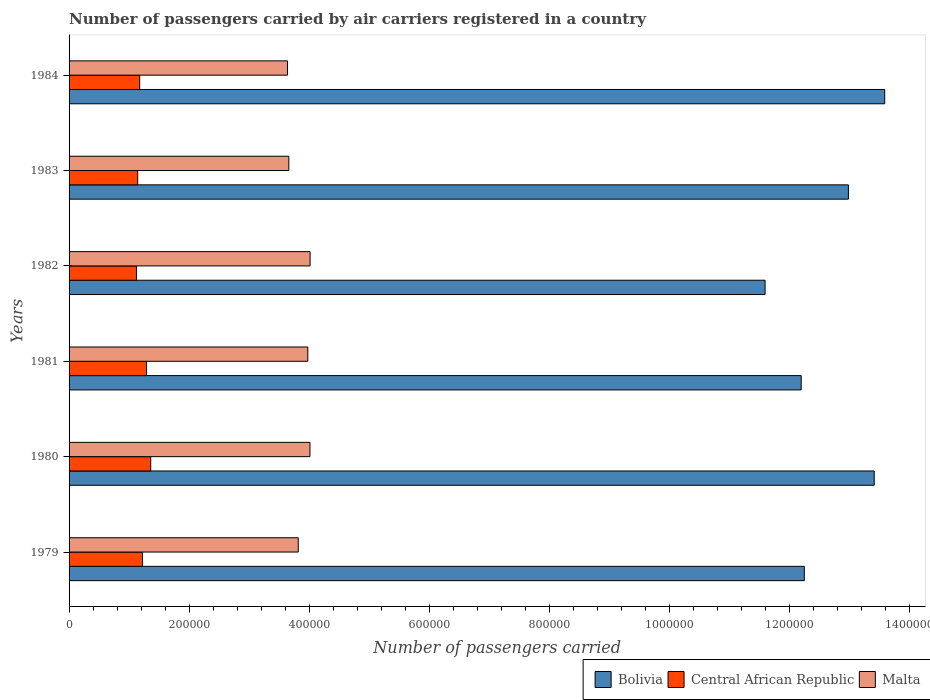How many bars are there on the 4th tick from the top?
Your response must be concise. 3. How many bars are there on the 5th tick from the bottom?
Your answer should be compact. 3. What is the label of the 5th group of bars from the top?
Offer a terse response. 1980. In how many cases, is the number of bars for a given year not equal to the number of legend labels?
Your response must be concise. 0. What is the number of passengers carried by air carriers in Bolivia in 1980?
Your answer should be compact. 1.34e+06. Across all years, what is the maximum number of passengers carried by air carriers in Malta?
Make the answer very short. 4.02e+05. Across all years, what is the minimum number of passengers carried by air carriers in Malta?
Keep it short and to the point. 3.64e+05. What is the total number of passengers carried by air carriers in Bolivia in the graph?
Keep it short and to the point. 7.61e+06. What is the difference between the number of passengers carried by air carriers in Bolivia in 1983 and that in 1984?
Offer a very short reply. -6.05e+04. What is the difference between the number of passengers carried by air carriers in Bolivia in 1979 and the number of passengers carried by air carriers in Malta in 1982?
Ensure brevity in your answer.  8.24e+05. What is the average number of passengers carried by air carriers in Bolivia per year?
Keep it short and to the point. 1.27e+06. In the year 1979, what is the difference between the number of passengers carried by air carriers in Bolivia and number of passengers carried by air carriers in Central African Republic?
Provide a short and direct response. 1.10e+06. In how many years, is the number of passengers carried by air carriers in Malta greater than 840000 ?
Provide a short and direct response. 0. What is the ratio of the number of passengers carried by air carriers in Bolivia in 1982 to that in 1984?
Give a very brief answer. 0.85. What is the difference between the highest and the second highest number of passengers carried by air carriers in Central African Republic?
Offer a terse response. 7000. What is the difference between the highest and the lowest number of passengers carried by air carriers in Central African Republic?
Provide a short and direct response. 2.38e+04. What does the 2nd bar from the top in 1979 represents?
Provide a short and direct response. Central African Republic. What does the 3rd bar from the bottom in 1982 represents?
Offer a terse response. Malta. Is it the case that in every year, the sum of the number of passengers carried by air carriers in Malta and number of passengers carried by air carriers in Bolivia is greater than the number of passengers carried by air carriers in Central African Republic?
Make the answer very short. Yes. Are all the bars in the graph horizontal?
Your answer should be very brief. Yes. What is the difference between two consecutive major ticks on the X-axis?
Your response must be concise. 2.00e+05. Does the graph contain any zero values?
Your response must be concise. No. How many legend labels are there?
Ensure brevity in your answer.  3. What is the title of the graph?
Provide a succinct answer. Number of passengers carried by air carriers registered in a country. What is the label or title of the X-axis?
Provide a short and direct response. Number of passengers carried. What is the label or title of the Y-axis?
Your answer should be very brief. Years. What is the Number of passengers carried of Bolivia in 1979?
Make the answer very short. 1.23e+06. What is the Number of passengers carried in Central African Republic in 1979?
Ensure brevity in your answer.  1.22e+05. What is the Number of passengers carried of Malta in 1979?
Provide a succinct answer. 3.82e+05. What is the Number of passengers carried in Bolivia in 1980?
Provide a short and direct response. 1.34e+06. What is the Number of passengers carried of Central African Republic in 1980?
Keep it short and to the point. 1.36e+05. What is the Number of passengers carried in Malta in 1980?
Provide a succinct answer. 4.02e+05. What is the Number of passengers carried of Bolivia in 1981?
Provide a succinct answer. 1.22e+06. What is the Number of passengers carried in Central African Republic in 1981?
Your response must be concise. 1.29e+05. What is the Number of passengers carried of Malta in 1981?
Give a very brief answer. 3.98e+05. What is the Number of passengers carried of Bolivia in 1982?
Your response must be concise. 1.16e+06. What is the Number of passengers carried in Central African Republic in 1982?
Your answer should be compact. 1.12e+05. What is the Number of passengers carried in Malta in 1982?
Offer a terse response. 4.02e+05. What is the Number of passengers carried of Bolivia in 1983?
Give a very brief answer. 1.30e+06. What is the Number of passengers carried in Central African Republic in 1983?
Offer a very short reply. 1.14e+05. What is the Number of passengers carried in Malta in 1983?
Keep it short and to the point. 3.66e+05. What is the Number of passengers carried in Bolivia in 1984?
Offer a very short reply. 1.36e+06. What is the Number of passengers carried of Central African Republic in 1984?
Your answer should be very brief. 1.18e+05. What is the Number of passengers carried in Malta in 1984?
Your response must be concise. 3.64e+05. Across all years, what is the maximum Number of passengers carried of Bolivia?
Make the answer very short. 1.36e+06. Across all years, what is the maximum Number of passengers carried in Central African Republic?
Give a very brief answer. 1.36e+05. Across all years, what is the maximum Number of passengers carried of Malta?
Offer a terse response. 4.02e+05. Across all years, what is the minimum Number of passengers carried in Bolivia?
Offer a very short reply. 1.16e+06. Across all years, what is the minimum Number of passengers carried of Central African Republic?
Ensure brevity in your answer.  1.12e+05. Across all years, what is the minimum Number of passengers carried of Malta?
Make the answer very short. 3.64e+05. What is the total Number of passengers carried in Bolivia in the graph?
Make the answer very short. 7.61e+06. What is the total Number of passengers carried in Central African Republic in the graph?
Give a very brief answer. 7.32e+05. What is the total Number of passengers carried in Malta in the graph?
Keep it short and to the point. 2.31e+06. What is the difference between the Number of passengers carried of Bolivia in 1979 and that in 1980?
Ensure brevity in your answer.  -1.16e+05. What is the difference between the Number of passengers carried in Central African Republic in 1979 and that in 1980?
Your answer should be very brief. -1.38e+04. What is the difference between the Number of passengers carried in Malta in 1979 and that in 1980?
Offer a terse response. -1.95e+04. What is the difference between the Number of passengers carried in Bolivia in 1979 and that in 1981?
Provide a short and direct response. 5200. What is the difference between the Number of passengers carried in Central African Republic in 1979 and that in 1981?
Offer a very short reply. -6800. What is the difference between the Number of passengers carried in Malta in 1979 and that in 1981?
Ensure brevity in your answer.  -1.59e+04. What is the difference between the Number of passengers carried in Bolivia in 1979 and that in 1982?
Keep it short and to the point. 6.54e+04. What is the difference between the Number of passengers carried in Malta in 1979 and that in 1982?
Offer a very short reply. -1.97e+04. What is the difference between the Number of passengers carried of Bolivia in 1979 and that in 1983?
Your answer should be very brief. -7.35e+04. What is the difference between the Number of passengers carried of Central African Republic in 1979 and that in 1983?
Offer a very short reply. 7900. What is the difference between the Number of passengers carried of Malta in 1979 and that in 1983?
Ensure brevity in your answer.  1.57e+04. What is the difference between the Number of passengers carried in Bolivia in 1979 and that in 1984?
Provide a succinct answer. -1.34e+05. What is the difference between the Number of passengers carried of Central African Republic in 1979 and that in 1984?
Ensure brevity in your answer.  4600. What is the difference between the Number of passengers carried of Malta in 1979 and that in 1984?
Your response must be concise. 1.79e+04. What is the difference between the Number of passengers carried in Bolivia in 1980 and that in 1981?
Your answer should be compact. 1.22e+05. What is the difference between the Number of passengers carried in Central African Republic in 1980 and that in 1981?
Offer a terse response. 7000. What is the difference between the Number of passengers carried in Malta in 1980 and that in 1981?
Your answer should be compact. 3600. What is the difference between the Number of passengers carried in Bolivia in 1980 and that in 1982?
Provide a succinct answer. 1.82e+05. What is the difference between the Number of passengers carried of Central African Republic in 1980 and that in 1982?
Give a very brief answer. 2.38e+04. What is the difference between the Number of passengers carried of Malta in 1980 and that in 1982?
Offer a very short reply. -200. What is the difference between the Number of passengers carried of Bolivia in 1980 and that in 1983?
Keep it short and to the point. 4.30e+04. What is the difference between the Number of passengers carried in Central African Republic in 1980 and that in 1983?
Your response must be concise. 2.17e+04. What is the difference between the Number of passengers carried of Malta in 1980 and that in 1983?
Keep it short and to the point. 3.52e+04. What is the difference between the Number of passengers carried of Bolivia in 1980 and that in 1984?
Your response must be concise. -1.75e+04. What is the difference between the Number of passengers carried of Central African Republic in 1980 and that in 1984?
Provide a succinct answer. 1.84e+04. What is the difference between the Number of passengers carried of Malta in 1980 and that in 1984?
Your response must be concise. 3.74e+04. What is the difference between the Number of passengers carried in Bolivia in 1981 and that in 1982?
Provide a succinct answer. 6.02e+04. What is the difference between the Number of passengers carried of Central African Republic in 1981 and that in 1982?
Provide a succinct answer. 1.68e+04. What is the difference between the Number of passengers carried of Malta in 1981 and that in 1982?
Your response must be concise. -3800. What is the difference between the Number of passengers carried of Bolivia in 1981 and that in 1983?
Provide a short and direct response. -7.87e+04. What is the difference between the Number of passengers carried of Central African Republic in 1981 and that in 1983?
Your response must be concise. 1.47e+04. What is the difference between the Number of passengers carried of Malta in 1981 and that in 1983?
Your answer should be compact. 3.16e+04. What is the difference between the Number of passengers carried in Bolivia in 1981 and that in 1984?
Your answer should be very brief. -1.39e+05. What is the difference between the Number of passengers carried in Central African Republic in 1981 and that in 1984?
Keep it short and to the point. 1.14e+04. What is the difference between the Number of passengers carried in Malta in 1981 and that in 1984?
Provide a short and direct response. 3.38e+04. What is the difference between the Number of passengers carried in Bolivia in 1982 and that in 1983?
Keep it short and to the point. -1.39e+05. What is the difference between the Number of passengers carried in Central African Republic in 1982 and that in 1983?
Provide a short and direct response. -2100. What is the difference between the Number of passengers carried of Malta in 1982 and that in 1983?
Your answer should be compact. 3.54e+04. What is the difference between the Number of passengers carried of Bolivia in 1982 and that in 1984?
Offer a very short reply. -1.99e+05. What is the difference between the Number of passengers carried in Central African Republic in 1982 and that in 1984?
Make the answer very short. -5400. What is the difference between the Number of passengers carried of Malta in 1982 and that in 1984?
Ensure brevity in your answer.  3.76e+04. What is the difference between the Number of passengers carried in Bolivia in 1983 and that in 1984?
Provide a short and direct response. -6.05e+04. What is the difference between the Number of passengers carried of Central African Republic in 1983 and that in 1984?
Give a very brief answer. -3300. What is the difference between the Number of passengers carried in Malta in 1983 and that in 1984?
Your answer should be very brief. 2200. What is the difference between the Number of passengers carried in Bolivia in 1979 and the Number of passengers carried in Central African Republic in 1980?
Your answer should be compact. 1.09e+06. What is the difference between the Number of passengers carried of Bolivia in 1979 and the Number of passengers carried of Malta in 1980?
Offer a terse response. 8.24e+05. What is the difference between the Number of passengers carried in Central African Republic in 1979 and the Number of passengers carried in Malta in 1980?
Keep it short and to the point. -2.79e+05. What is the difference between the Number of passengers carried of Bolivia in 1979 and the Number of passengers carried of Central African Republic in 1981?
Offer a terse response. 1.10e+06. What is the difference between the Number of passengers carried in Bolivia in 1979 and the Number of passengers carried in Malta in 1981?
Offer a very short reply. 8.28e+05. What is the difference between the Number of passengers carried of Central African Republic in 1979 and the Number of passengers carried of Malta in 1981?
Ensure brevity in your answer.  -2.76e+05. What is the difference between the Number of passengers carried of Bolivia in 1979 and the Number of passengers carried of Central African Republic in 1982?
Give a very brief answer. 1.11e+06. What is the difference between the Number of passengers carried in Bolivia in 1979 and the Number of passengers carried in Malta in 1982?
Make the answer very short. 8.24e+05. What is the difference between the Number of passengers carried in Central African Republic in 1979 and the Number of passengers carried in Malta in 1982?
Your response must be concise. -2.79e+05. What is the difference between the Number of passengers carried in Bolivia in 1979 and the Number of passengers carried in Central African Republic in 1983?
Offer a terse response. 1.11e+06. What is the difference between the Number of passengers carried of Bolivia in 1979 and the Number of passengers carried of Malta in 1983?
Your answer should be very brief. 8.59e+05. What is the difference between the Number of passengers carried of Central African Republic in 1979 and the Number of passengers carried of Malta in 1983?
Ensure brevity in your answer.  -2.44e+05. What is the difference between the Number of passengers carried in Bolivia in 1979 and the Number of passengers carried in Central African Republic in 1984?
Provide a succinct answer. 1.11e+06. What is the difference between the Number of passengers carried in Bolivia in 1979 and the Number of passengers carried in Malta in 1984?
Make the answer very short. 8.61e+05. What is the difference between the Number of passengers carried in Central African Republic in 1979 and the Number of passengers carried in Malta in 1984?
Ensure brevity in your answer.  -2.42e+05. What is the difference between the Number of passengers carried of Bolivia in 1980 and the Number of passengers carried of Central African Republic in 1981?
Give a very brief answer. 1.21e+06. What is the difference between the Number of passengers carried in Bolivia in 1980 and the Number of passengers carried in Malta in 1981?
Your answer should be compact. 9.44e+05. What is the difference between the Number of passengers carried in Central African Republic in 1980 and the Number of passengers carried in Malta in 1981?
Provide a short and direct response. -2.62e+05. What is the difference between the Number of passengers carried in Bolivia in 1980 and the Number of passengers carried in Central African Republic in 1982?
Your answer should be compact. 1.23e+06. What is the difference between the Number of passengers carried in Bolivia in 1980 and the Number of passengers carried in Malta in 1982?
Your answer should be very brief. 9.40e+05. What is the difference between the Number of passengers carried of Central African Republic in 1980 and the Number of passengers carried of Malta in 1982?
Keep it short and to the point. -2.66e+05. What is the difference between the Number of passengers carried in Bolivia in 1980 and the Number of passengers carried in Central African Republic in 1983?
Give a very brief answer. 1.23e+06. What is the difference between the Number of passengers carried in Bolivia in 1980 and the Number of passengers carried in Malta in 1983?
Your answer should be very brief. 9.76e+05. What is the difference between the Number of passengers carried in Central African Republic in 1980 and the Number of passengers carried in Malta in 1983?
Your response must be concise. -2.30e+05. What is the difference between the Number of passengers carried in Bolivia in 1980 and the Number of passengers carried in Central African Republic in 1984?
Provide a succinct answer. 1.22e+06. What is the difference between the Number of passengers carried in Bolivia in 1980 and the Number of passengers carried in Malta in 1984?
Your response must be concise. 9.78e+05. What is the difference between the Number of passengers carried in Central African Republic in 1980 and the Number of passengers carried in Malta in 1984?
Keep it short and to the point. -2.28e+05. What is the difference between the Number of passengers carried of Bolivia in 1981 and the Number of passengers carried of Central African Republic in 1982?
Offer a terse response. 1.11e+06. What is the difference between the Number of passengers carried of Bolivia in 1981 and the Number of passengers carried of Malta in 1982?
Your answer should be very brief. 8.19e+05. What is the difference between the Number of passengers carried of Central African Republic in 1981 and the Number of passengers carried of Malta in 1982?
Ensure brevity in your answer.  -2.73e+05. What is the difference between the Number of passengers carried in Bolivia in 1981 and the Number of passengers carried in Central African Republic in 1983?
Your answer should be very brief. 1.11e+06. What is the difference between the Number of passengers carried in Bolivia in 1981 and the Number of passengers carried in Malta in 1983?
Offer a terse response. 8.54e+05. What is the difference between the Number of passengers carried of Central African Republic in 1981 and the Number of passengers carried of Malta in 1983?
Offer a terse response. -2.37e+05. What is the difference between the Number of passengers carried of Bolivia in 1981 and the Number of passengers carried of Central African Republic in 1984?
Ensure brevity in your answer.  1.10e+06. What is the difference between the Number of passengers carried of Bolivia in 1981 and the Number of passengers carried of Malta in 1984?
Keep it short and to the point. 8.56e+05. What is the difference between the Number of passengers carried in Central African Republic in 1981 and the Number of passengers carried in Malta in 1984?
Ensure brevity in your answer.  -2.35e+05. What is the difference between the Number of passengers carried in Bolivia in 1982 and the Number of passengers carried in Central African Republic in 1983?
Your answer should be compact. 1.05e+06. What is the difference between the Number of passengers carried in Bolivia in 1982 and the Number of passengers carried in Malta in 1983?
Offer a very short reply. 7.94e+05. What is the difference between the Number of passengers carried of Central African Republic in 1982 and the Number of passengers carried of Malta in 1983?
Provide a short and direct response. -2.54e+05. What is the difference between the Number of passengers carried of Bolivia in 1982 and the Number of passengers carried of Central African Republic in 1984?
Make the answer very short. 1.04e+06. What is the difference between the Number of passengers carried of Bolivia in 1982 and the Number of passengers carried of Malta in 1984?
Your response must be concise. 7.96e+05. What is the difference between the Number of passengers carried of Central African Republic in 1982 and the Number of passengers carried of Malta in 1984?
Provide a short and direct response. -2.52e+05. What is the difference between the Number of passengers carried in Bolivia in 1983 and the Number of passengers carried in Central African Republic in 1984?
Provide a succinct answer. 1.18e+06. What is the difference between the Number of passengers carried in Bolivia in 1983 and the Number of passengers carried in Malta in 1984?
Ensure brevity in your answer.  9.35e+05. What is the difference between the Number of passengers carried of Central African Republic in 1983 and the Number of passengers carried of Malta in 1984?
Give a very brief answer. -2.50e+05. What is the average Number of passengers carried of Bolivia per year?
Offer a very short reply. 1.27e+06. What is the average Number of passengers carried in Central African Republic per year?
Your response must be concise. 1.22e+05. What is the average Number of passengers carried in Malta per year?
Your response must be concise. 3.86e+05. In the year 1979, what is the difference between the Number of passengers carried in Bolivia and Number of passengers carried in Central African Republic?
Provide a short and direct response. 1.10e+06. In the year 1979, what is the difference between the Number of passengers carried in Bolivia and Number of passengers carried in Malta?
Offer a terse response. 8.44e+05. In the year 1979, what is the difference between the Number of passengers carried of Central African Republic and Number of passengers carried of Malta?
Ensure brevity in your answer.  -2.60e+05. In the year 1980, what is the difference between the Number of passengers carried of Bolivia and Number of passengers carried of Central African Republic?
Offer a very short reply. 1.21e+06. In the year 1980, what is the difference between the Number of passengers carried of Bolivia and Number of passengers carried of Malta?
Keep it short and to the point. 9.40e+05. In the year 1980, what is the difference between the Number of passengers carried of Central African Republic and Number of passengers carried of Malta?
Offer a terse response. -2.65e+05. In the year 1981, what is the difference between the Number of passengers carried of Bolivia and Number of passengers carried of Central African Republic?
Your answer should be compact. 1.09e+06. In the year 1981, what is the difference between the Number of passengers carried of Bolivia and Number of passengers carried of Malta?
Your answer should be compact. 8.22e+05. In the year 1981, what is the difference between the Number of passengers carried of Central African Republic and Number of passengers carried of Malta?
Provide a short and direct response. -2.69e+05. In the year 1982, what is the difference between the Number of passengers carried of Bolivia and Number of passengers carried of Central African Republic?
Make the answer very short. 1.05e+06. In the year 1982, what is the difference between the Number of passengers carried in Bolivia and Number of passengers carried in Malta?
Provide a short and direct response. 7.58e+05. In the year 1982, what is the difference between the Number of passengers carried of Central African Republic and Number of passengers carried of Malta?
Keep it short and to the point. -2.89e+05. In the year 1983, what is the difference between the Number of passengers carried in Bolivia and Number of passengers carried in Central African Republic?
Your response must be concise. 1.18e+06. In the year 1983, what is the difference between the Number of passengers carried of Bolivia and Number of passengers carried of Malta?
Give a very brief answer. 9.33e+05. In the year 1983, what is the difference between the Number of passengers carried in Central African Republic and Number of passengers carried in Malta?
Your answer should be very brief. -2.52e+05. In the year 1984, what is the difference between the Number of passengers carried of Bolivia and Number of passengers carried of Central African Republic?
Your answer should be compact. 1.24e+06. In the year 1984, what is the difference between the Number of passengers carried of Bolivia and Number of passengers carried of Malta?
Provide a short and direct response. 9.95e+05. In the year 1984, what is the difference between the Number of passengers carried of Central African Republic and Number of passengers carried of Malta?
Your answer should be compact. -2.46e+05. What is the ratio of the Number of passengers carried of Bolivia in 1979 to that in 1980?
Offer a terse response. 0.91. What is the ratio of the Number of passengers carried of Central African Republic in 1979 to that in 1980?
Make the answer very short. 0.9. What is the ratio of the Number of passengers carried in Malta in 1979 to that in 1980?
Your response must be concise. 0.95. What is the ratio of the Number of passengers carried of Central African Republic in 1979 to that in 1981?
Ensure brevity in your answer.  0.95. What is the ratio of the Number of passengers carried of Malta in 1979 to that in 1981?
Your response must be concise. 0.96. What is the ratio of the Number of passengers carried in Bolivia in 1979 to that in 1982?
Give a very brief answer. 1.06. What is the ratio of the Number of passengers carried of Central African Republic in 1979 to that in 1982?
Provide a short and direct response. 1.09. What is the ratio of the Number of passengers carried in Malta in 1979 to that in 1982?
Ensure brevity in your answer.  0.95. What is the ratio of the Number of passengers carried of Bolivia in 1979 to that in 1983?
Offer a terse response. 0.94. What is the ratio of the Number of passengers carried of Central African Republic in 1979 to that in 1983?
Give a very brief answer. 1.07. What is the ratio of the Number of passengers carried in Malta in 1979 to that in 1983?
Provide a short and direct response. 1.04. What is the ratio of the Number of passengers carried of Bolivia in 1979 to that in 1984?
Make the answer very short. 0.9. What is the ratio of the Number of passengers carried in Central African Republic in 1979 to that in 1984?
Provide a succinct answer. 1.04. What is the ratio of the Number of passengers carried of Malta in 1979 to that in 1984?
Your answer should be compact. 1.05. What is the ratio of the Number of passengers carried of Bolivia in 1980 to that in 1981?
Your answer should be compact. 1.1. What is the ratio of the Number of passengers carried in Central African Republic in 1980 to that in 1981?
Make the answer very short. 1.05. What is the ratio of the Number of passengers carried in Bolivia in 1980 to that in 1982?
Keep it short and to the point. 1.16. What is the ratio of the Number of passengers carried of Central African Republic in 1980 to that in 1982?
Offer a terse response. 1.21. What is the ratio of the Number of passengers carried in Malta in 1980 to that in 1982?
Ensure brevity in your answer.  1. What is the ratio of the Number of passengers carried of Bolivia in 1980 to that in 1983?
Offer a very short reply. 1.03. What is the ratio of the Number of passengers carried of Central African Republic in 1980 to that in 1983?
Your response must be concise. 1.19. What is the ratio of the Number of passengers carried of Malta in 1980 to that in 1983?
Give a very brief answer. 1.1. What is the ratio of the Number of passengers carried of Bolivia in 1980 to that in 1984?
Your answer should be very brief. 0.99. What is the ratio of the Number of passengers carried in Central African Republic in 1980 to that in 1984?
Offer a terse response. 1.16. What is the ratio of the Number of passengers carried of Malta in 1980 to that in 1984?
Provide a succinct answer. 1.1. What is the ratio of the Number of passengers carried of Bolivia in 1981 to that in 1982?
Keep it short and to the point. 1.05. What is the ratio of the Number of passengers carried of Central African Republic in 1981 to that in 1982?
Offer a terse response. 1.15. What is the ratio of the Number of passengers carried in Bolivia in 1981 to that in 1983?
Your answer should be very brief. 0.94. What is the ratio of the Number of passengers carried of Central African Republic in 1981 to that in 1983?
Offer a terse response. 1.13. What is the ratio of the Number of passengers carried in Malta in 1981 to that in 1983?
Make the answer very short. 1.09. What is the ratio of the Number of passengers carried in Bolivia in 1981 to that in 1984?
Offer a very short reply. 0.9. What is the ratio of the Number of passengers carried of Central African Republic in 1981 to that in 1984?
Provide a succinct answer. 1.1. What is the ratio of the Number of passengers carried in Malta in 1981 to that in 1984?
Make the answer very short. 1.09. What is the ratio of the Number of passengers carried in Bolivia in 1982 to that in 1983?
Offer a terse response. 0.89. What is the ratio of the Number of passengers carried of Central African Republic in 1982 to that in 1983?
Give a very brief answer. 0.98. What is the ratio of the Number of passengers carried of Malta in 1982 to that in 1983?
Your answer should be compact. 1.1. What is the ratio of the Number of passengers carried of Bolivia in 1982 to that in 1984?
Make the answer very short. 0.85. What is the ratio of the Number of passengers carried of Central African Republic in 1982 to that in 1984?
Your answer should be very brief. 0.95. What is the ratio of the Number of passengers carried in Malta in 1982 to that in 1984?
Provide a succinct answer. 1.1. What is the ratio of the Number of passengers carried in Bolivia in 1983 to that in 1984?
Provide a short and direct response. 0.96. What is the difference between the highest and the second highest Number of passengers carried of Bolivia?
Your answer should be very brief. 1.75e+04. What is the difference between the highest and the second highest Number of passengers carried of Central African Republic?
Offer a very short reply. 7000. What is the difference between the highest and the second highest Number of passengers carried of Malta?
Offer a very short reply. 200. What is the difference between the highest and the lowest Number of passengers carried in Bolivia?
Provide a succinct answer. 1.99e+05. What is the difference between the highest and the lowest Number of passengers carried of Central African Republic?
Provide a succinct answer. 2.38e+04. What is the difference between the highest and the lowest Number of passengers carried of Malta?
Provide a short and direct response. 3.76e+04. 